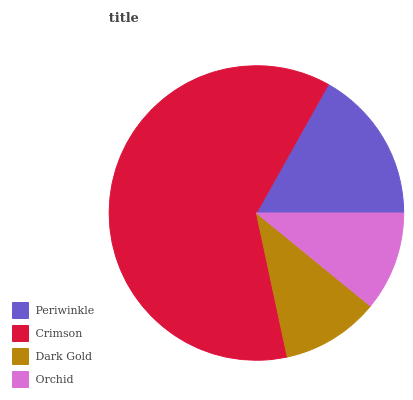Is Dark Gold the minimum?
Answer yes or no. Yes. Is Crimson the maximum?
Answer yes or no. Yes. Is Crimson the minimum?
Answer yes or no. No. Is Dark Gold the maximum?
Answer yes or no. No. Is Crimson greater than Dark Gold?
Answer yes or no. Yes. Is Dark Gold less than Crimson?
Answer yes or no. Yes. Is Dark Gold greater than Crimson?
Answer yes or no. No. Is Crimson less than Dark Gold?
Answer yes or no. No. Is Periwinkle the high median?
Answer yes or no. Yes. Is Orchid the low median?
Answer yes or no. Yes. Is Orchid the high median?
Answer yes or no. No. Is Dark Gold the low median?
Answer yes or no. No. 